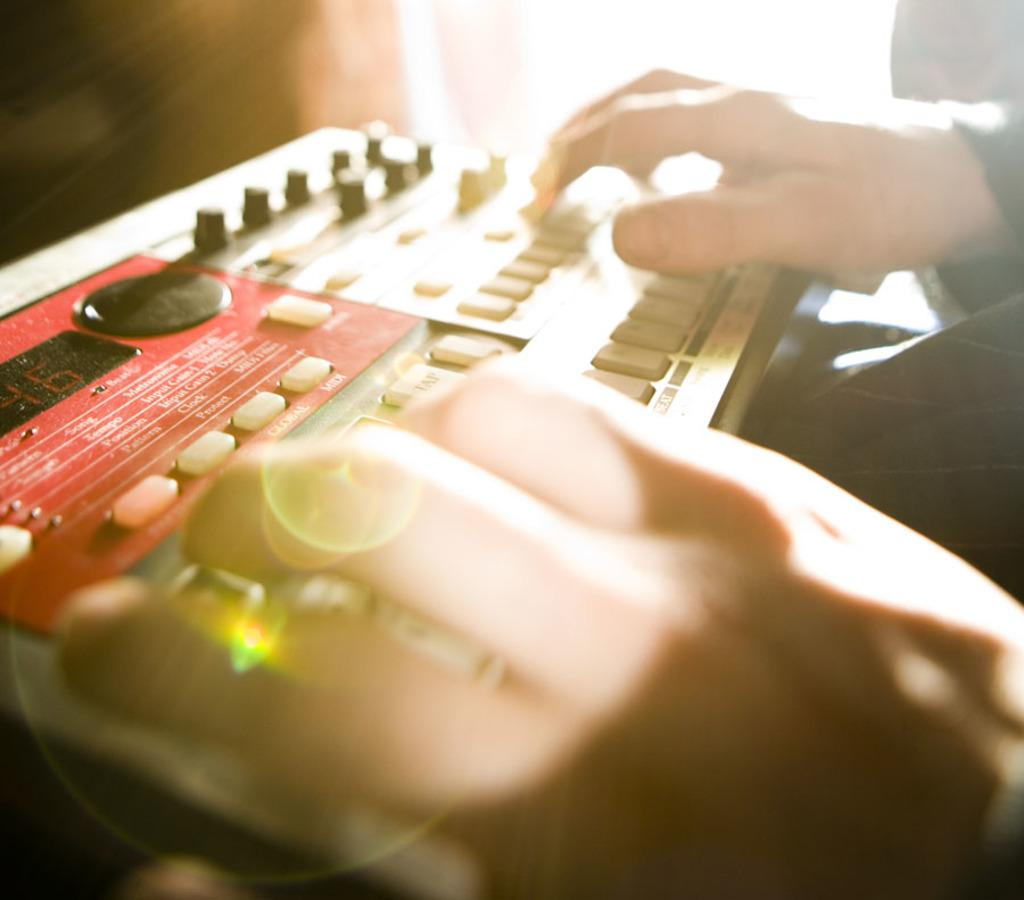What can be seen on the right side of the image? There is a person on the right side of the image. What is the person doing in the image? The person is placing both hands on a device. Can you describe the device the person is using? The device has buttons and a screen. What is the appearance of the background in the image? The background of the image is blurred. Can you tell me how much powder is in the kettle in the image? There is no kettle or powder present in the image. 